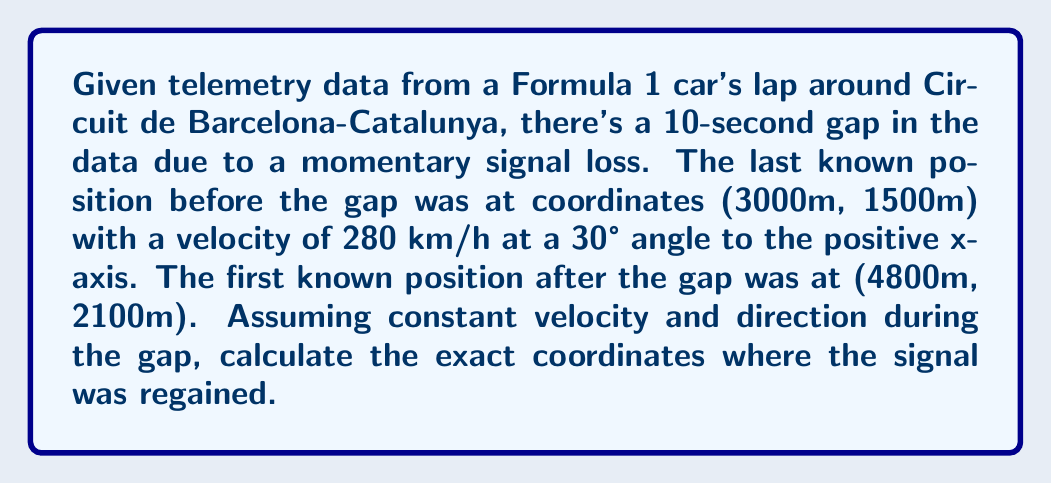Show me your answer to this math problem. Let's approach this step-by-step:

1) First, we need to convert the velocity from km/h to m/s:
   $$ 280 \frac{km}{h} = 280 * \frac{1000}{3600} \frac{m}{s} = 77.78 \frac{m}{s} $$

2) Now, we can break down the velocity into x and y components:
   $$ v_x = 77.78 * \cos(30°) = 67.33 \frac{m}{s} $$
   $$ v_y = 77.78 * \sin(30°) = 38.89 \frac{m}{s} $$

3) During the 10-second gap, the car would have traveled:
   $$ \Delta x = 67.33 * 10 = 673.3 m $$
   $$ \Delta y = 38.89 * 10 = 388.9 m $$

4) So, the predicted position after 10 seconds would be:
   $$ x = 3000 + 673.3 = 3673.3 m $$
   $$ y = 1500 + 388.9 = 1888.9 m $$

5) However, we know the actual position after the gap was (4800m, 2100m). The difference between the predicted and actual positions is:
   $$ \Delta x = 4800 - 3673.3 = 1126.7 m $$
   $$ \Delta y = 2100 - 1888.9 = 211.1 m $$

6) To find when the signal was regained, we need to determine what fraction of this additional distance was covered in the 10-second gap:
   $$ \text{Fraction} = \frac{10s}{\text{Total time}} = \frac{673.3}{1126.7} = 0.5975 $$

7) Therefore, the coordinates where the signal was regained are:
   $$ x = 3000 + 0.5975 * 1800 = 4075.5 m $$
   $$ y = 1500 + 0.5975 * 600 = 1858.5 m $$
Answer: (4075.5m, 1858.5m) 